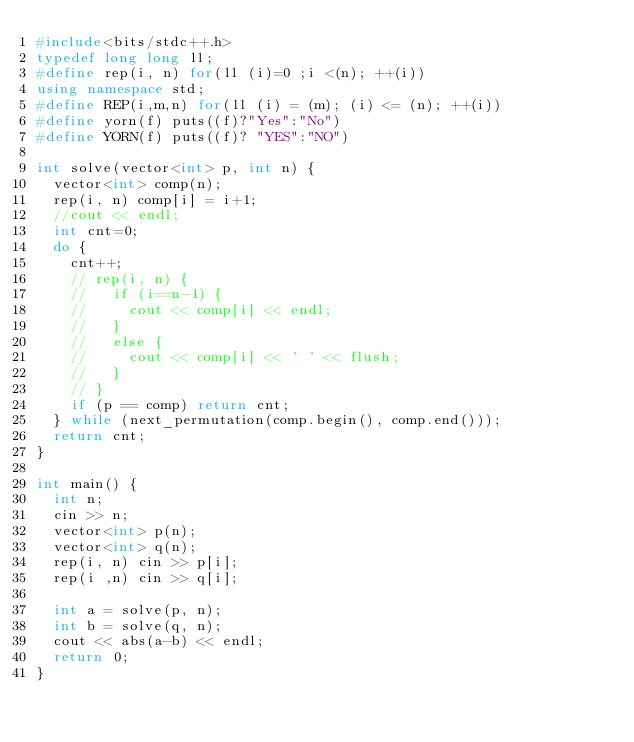<code> <loc_0><loc_0><loc_500><loc_500><_C++_>#include<bits/stdc++.h>
typedef long long ll;
#define rep(i, n) for(ll (i)=0 ;i <(n); ++(i))
using namespace std;
#define REP(i,m,n) for(ll (i) = (m); (i) <= (n); ++(i))
#define yorn(f) puts((f)?"Yes":"No")
#define YORN(f) puts((f)? "YES":"NO")

int solve(vector<int> p, int n) {
  vector<int> comp(n);
  rep(i, n) comp[i] = i+1;
  //cout << endl;
  int cnt=0;
  do {
    cnt++;
    // rep(i, n) {
    //   if (i==n-1) {
    //     cout << comp[i] << endl;
    //   }
    //   else {
    //     cout << comp[i] << ' ' << flush;
    //   }
    // }
    if (p == comp) return cnt;
  } while (next_permutation(comp.begin(), comp.end()));
  return cnt;
}

int main() {
  int n;
  cin >> n;
  vector<int> p(n);
  vector<int> q(n);
  rep(i, n) cin >> p[i];
  rep(i ,n) cin >> q[i];

  int a = solve(p, n);
  int b = solve(q, n);
  cout << abs(a-b) << endl;
  return 0;
}</code> 